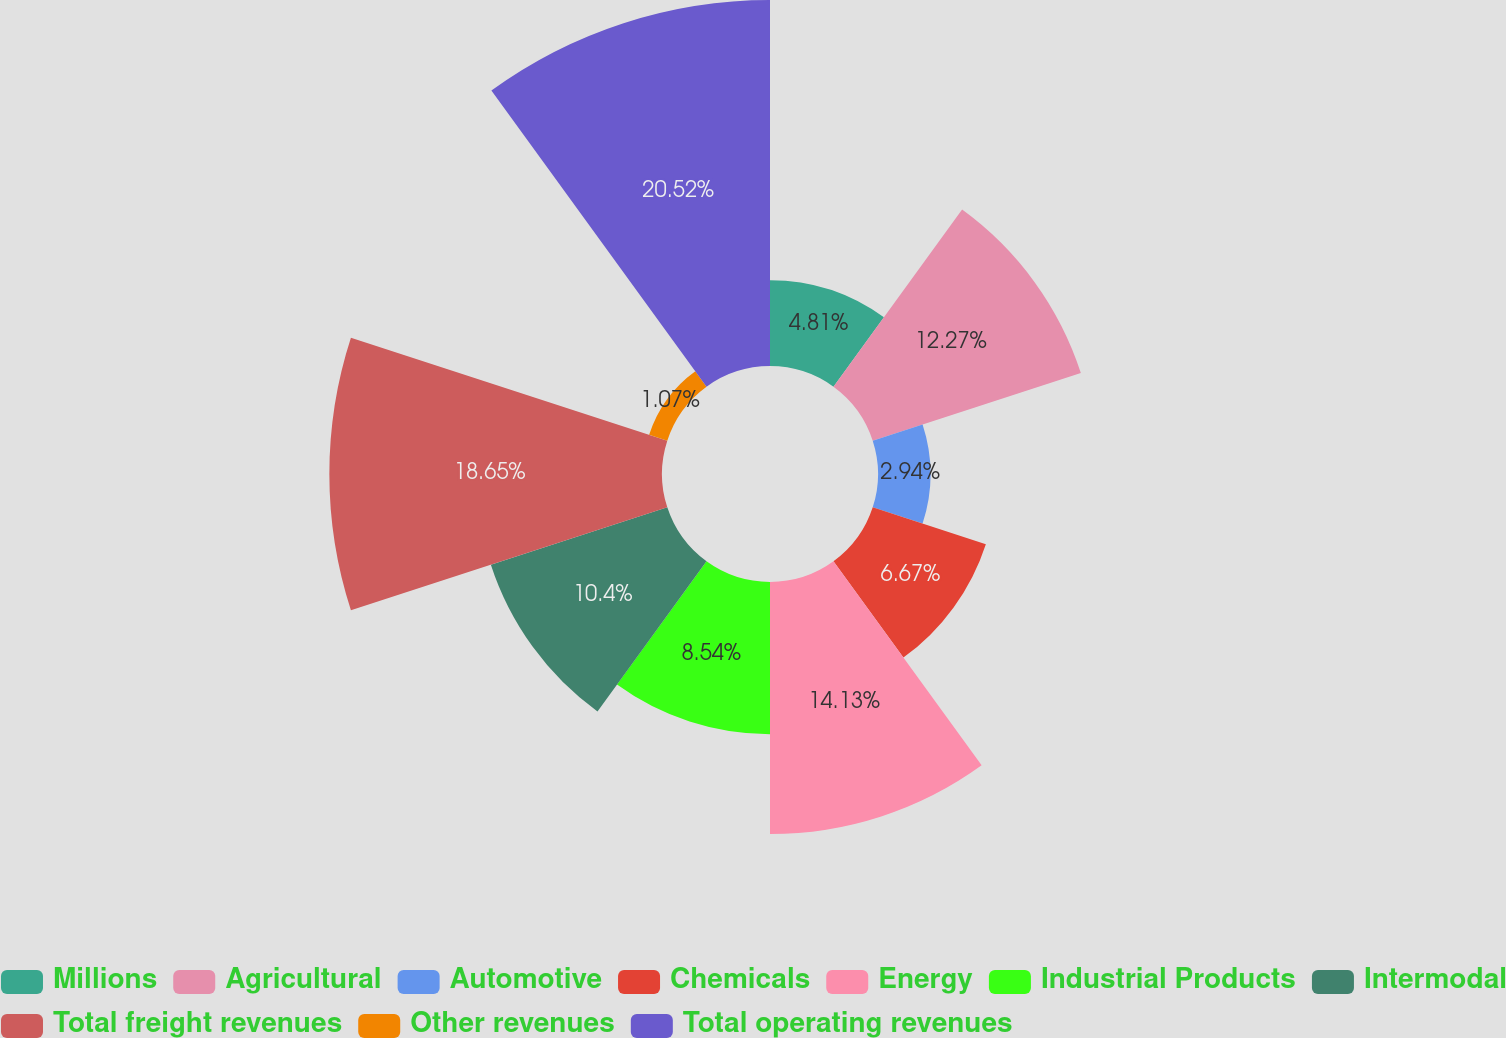Convert chart. <chart><loc_0><loc_0><loc_500><loc_500><pie_chart><fcel>Millions<fcel>Agricultural<fcel>Automotive<fcel>Chemicals<fcel>Energy<fcel>Industrial Products<fcel>Intermodal<fcel>Total freight revenues<fcel>Other revenues<fcel>Total operating revenues<nl><fcel>4.81%<fcel>12.27%<fcel>2.94%<fcel>6.67%<fcel>14.13%<fcel>8.54%<fcel>10.4%<fcel>18.65%<fcel>1.07%<fcel>20.52%<nl></chart> 